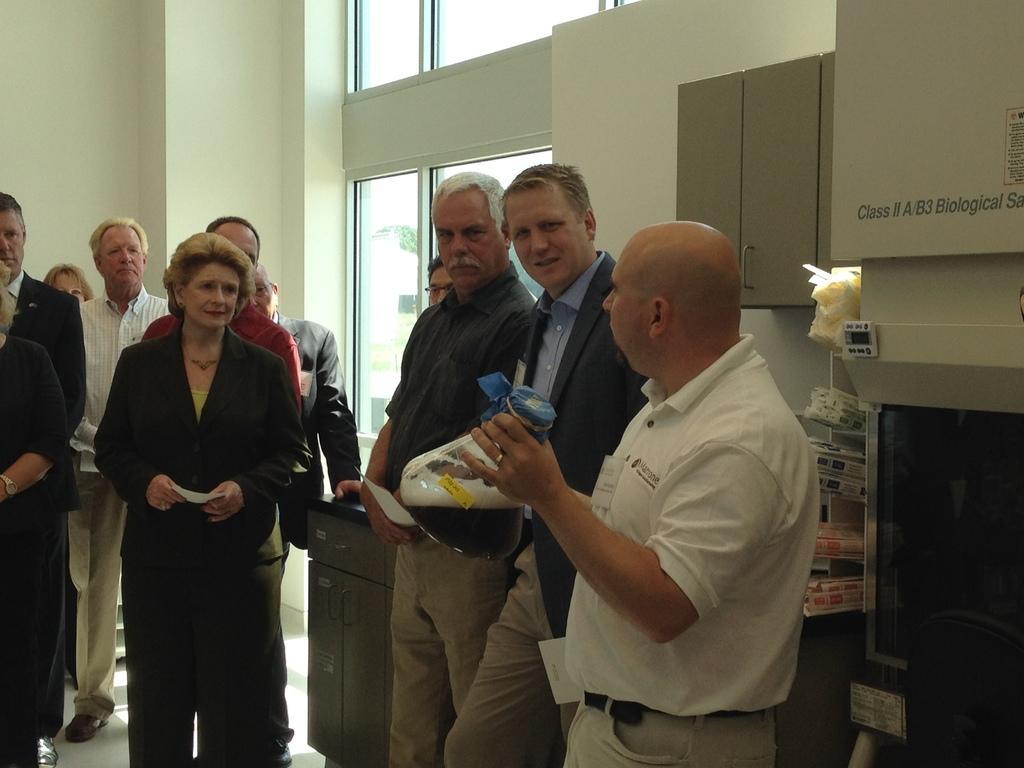Can you describe this image briefly? In the picture we can see some people are standing on the floor and they are wearing a blazer, shirts and tie and in the background we can see a wall with a glass window. 